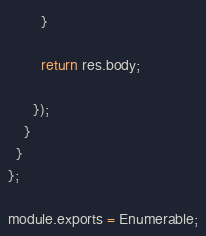<code> <loc_0><loc_0><loc_500><loc_500><_JavaScript_>        }

        return res.body;

      });
    }
  }
};

module.exports = Enumerable;
</code> 